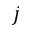<formula> <loc_0><loc_0><loc_500><loc_500>j</formula> 